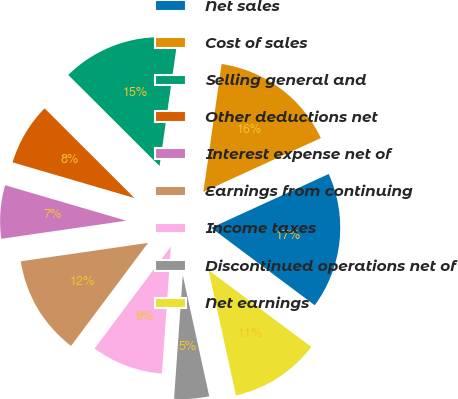Convert chart. <chart><loc_0><loc_0><loc_500><loc_500><pie_chart><fcel>Net sales<fcel>Cost of sales<fcel>Selling general and<fcel>Other deductions net<fcel>Interest expense net of<fcel>Earnings from continuing<fcel>Income taxes<fcel>Discontinued operations net of<fcel>Net earnings<nl><fcel>17.05%<fcel>15.91%<fcel>14.77%<fcel>7.95%<fcel>6.82%<fcel>12.5%<fcel>9.09%<fcel>4.55%<fcel>11.36%<nl></chart> 